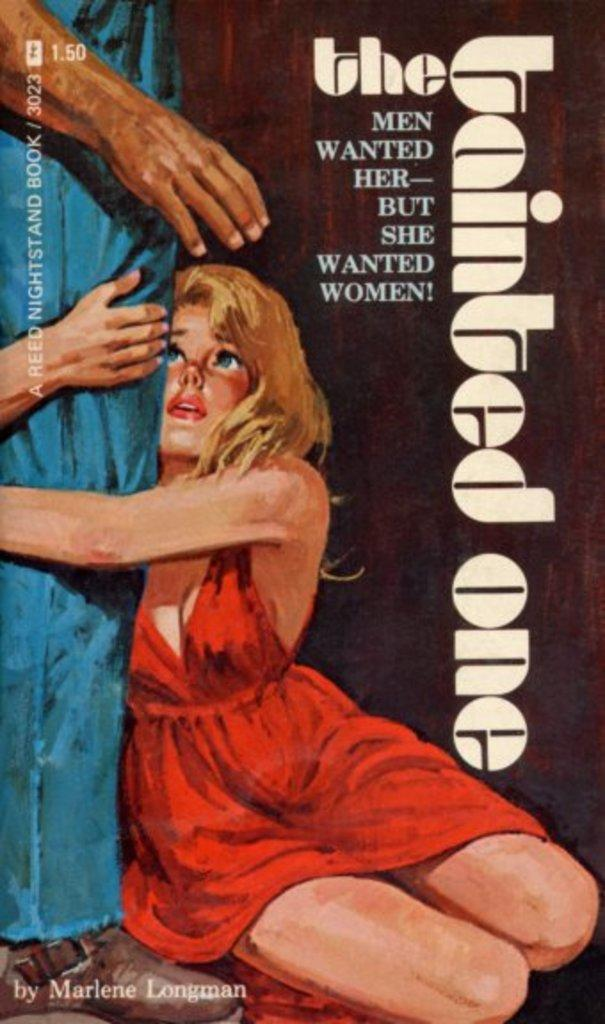<image>
Describe the image concisely. a copy of the book the tainted one by marlene longman. 